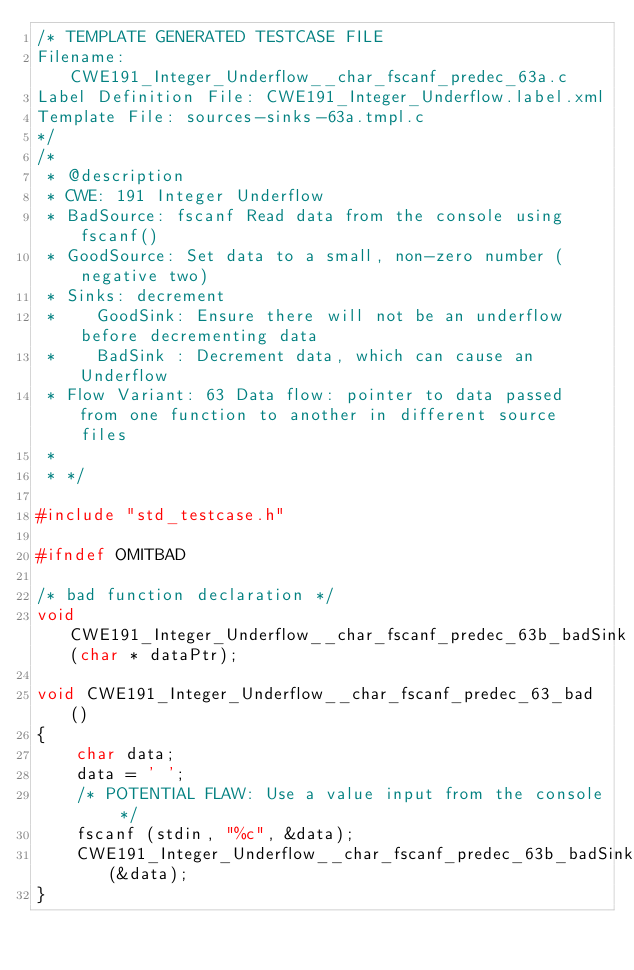<code> <loc_0><loc_0><loc_500><loc_500><_C_>/* TEMPLATE GENERATED TESTCASE FILE
Filename: CWE191_Integer_Underflow__char_fscanf_predec_63a.c
Label Definition File: CWE191_Integer_Underflow.label.xml
Template File: sources-sinks-63a.tmpl.c
*/
/*
 * @description
 * CWE: 191 Integer Underflow
 * BadSource: fscanf Read data from the console using fscanf()
 * GoodSource: Set data to a small, non-zero number (negative two)
 * Sinks: decrement
 *    GoodSink: Ensure there will not be an underflow before decrementing data
 *    BadSink : Decrement data, which can cause an Underflow
 * Flow Variant: 63 Data flow: pointer to data passed from one function to another in different source files
 *
 * */

#include "std_testcase.h"

#ifndef OMITBAD

/* bad function declaration */
void CWE191_Integer_Underflow__char_fscanf_predec_63b_badSink(char * dataPtr);

void CWE191_Integer_Underflow__char_fscanf_predec_63_bad()
{
    char data;
    data = ' ';
    /* POTENTIAL FLAW: Use a value input from the console */
    fscanf (stdin, "%c", &data);
    CWE191_Integer_Underflow__char_fscanf_predec_63b_badSink(&data);
}
</code> 